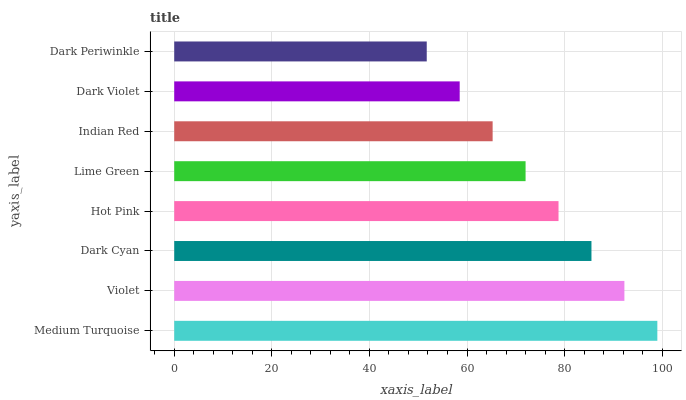Is Dark Periwinkle the minimum?
Answer yes or no. Yes. Is Medium Turquoise the maximum?
Answer yes or no. Yes. Is Violet the minimum?
Answer yes or no. No. Is Violet the maximum?
Answer yes or no. No. Is Medium Turquoise greater than Violet?
Answer yes or no. Yes. Is Violet less than Medium Turquoise?
Answer yes or no. Yes. Is Violet greater than Medium Turquoise?
Answer yes or no. No. Is Medium Turquoise less than Violet?
Answer yes or no. No. Is Hot Pink the high median?
Answer yes or no. Yes. Is Lime Green the low median?
Answer yes or no. Yes. Is Dark Periwinkle the high median?
Answer yes or no. No. Is Dark Cyan the low median?
Answer yes or no. No. 